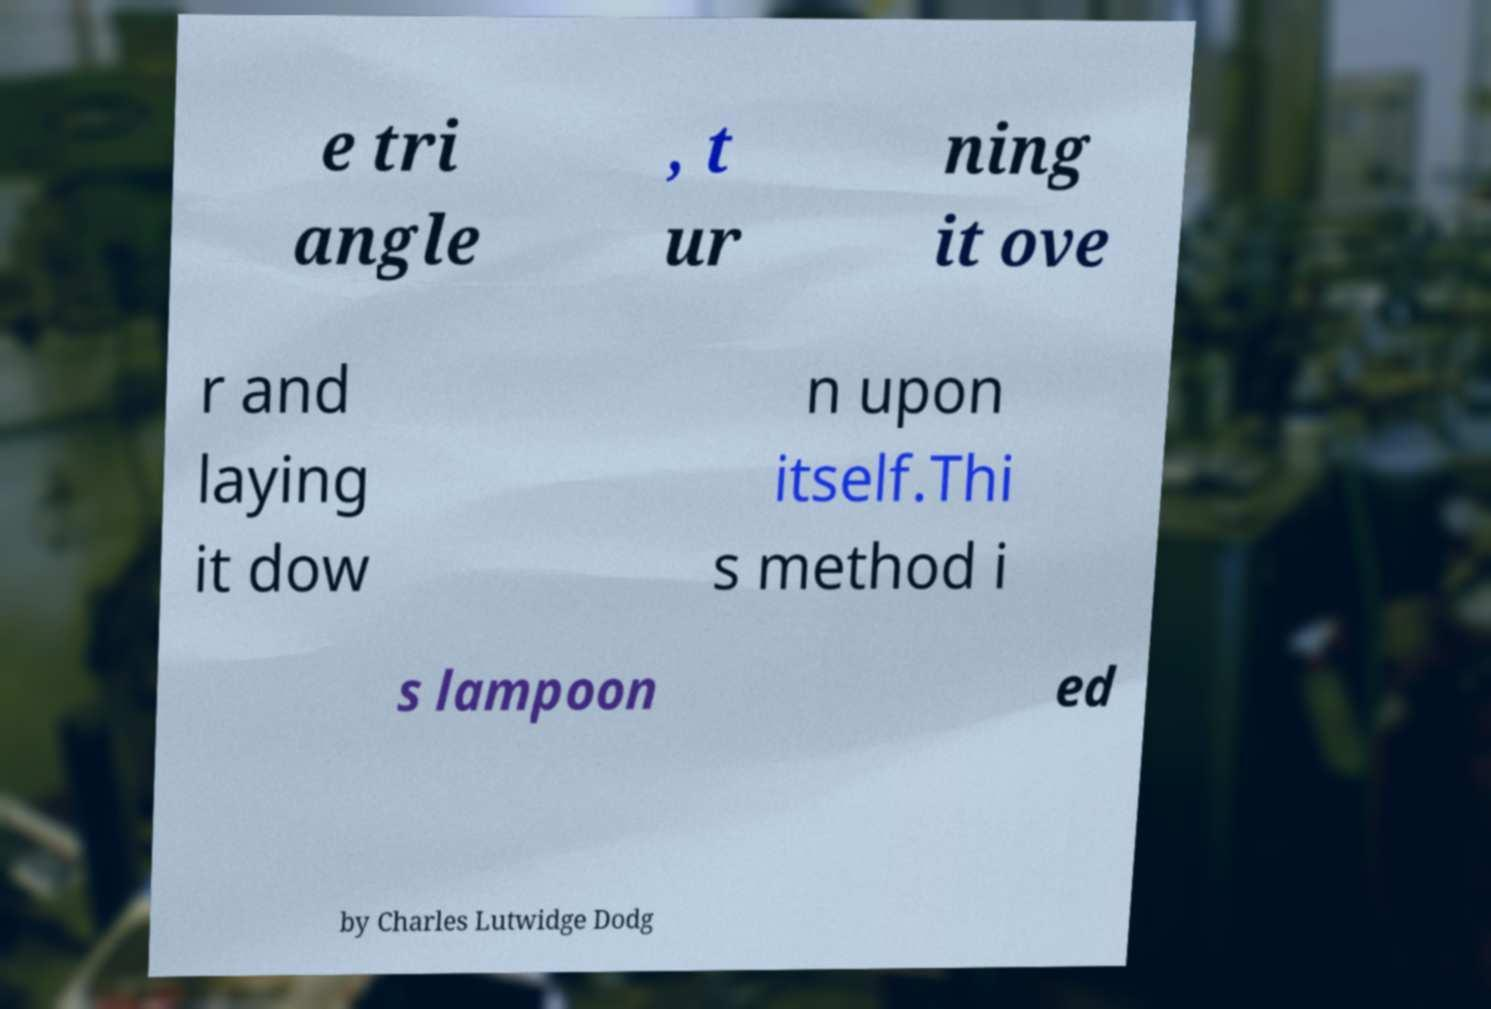What messages or text are displayed in this image? I need them in a readable, typed format. e tri angle , t ur ning it ove r and laying it dow n upon itself.Thi s method i s lampoon ed by Charles Lutwidge Dodg 